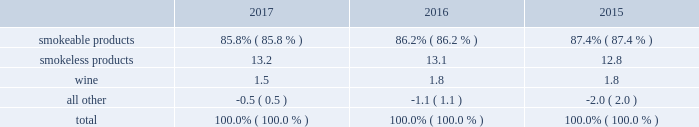10-k altria ar release tuesday , february 27 , 2018 10:00pm andra design llc the relative percentages of operating companies income ( loss ) attributable to each reportable segment and the all other category were as follows: .
For items affecting the comparability of the relative percentages of operating companies income ( loss ) attributable to each reportable segment , see note 15 .
Narrative description of business portions of the information called for by this item are included in operating results by business segment in item 7 .
Management 2019s discussion and analysis of financial condition and results of operations of this annual report on form 10-k ( 201citem 7 201d ) .
Tobacco space altria group , inc . 2019s tobacco operating companies include pm usa , usstc and other subsidiaries of ust , middleton , nu mark and nat sherman .
Altria group distribution company provides sales and distribution services to altria group , inc . 2019s tobacco operating companies .
The products of altria group , inc . 2019s tobacco subsidiaries include smokeable tobacco products , consisting of cigarettes manufactured and sold by pm usa and nat sherman , machine- made large cigars and pipe tobacco manufactured and sold by middleton and premium cigars sold by nat sherman ; smokeless tobacco products manufactured and sold by usstc ; and innovative tobacco products , including e-vapor products manufactured and sold by nu mark .
Cigarettes : pm usa is the largest cigarette company in the united states .
Marlboro , the principal cigarette brand of pm usa , has been the largest-selling cigarette brand in the united states for over 40 years .
Nat sherman sells substantially all of its super premium cigarettes in the united states .
Total smokeable products segment 2019s cigarettes shipment volume in the united states was 116.6 billion units in 2017 , a decrease of 5.1% ( 5.1 % ) from cigars : middleton is engaged in the manufacture and sale of machine-made large cigars and pipe tobacco .
Middleton contracts with a third-party importer to supply a majority of its cigars and sells substantially all of its cigars to customers in the united states .
Black & mild is the principal cigar brand of middleton .
Nat sherman sources all of its cigars from third-party suppliers and sells substantially all of its cigars to customers in the united states .
Total smokeable products segment 2019s cigars shipment volume was approximately 1.5 billion units in 2017 , an increase of 9.9% ( 9.9 % ) from 2016 .
Smokeless tobacco products : usstc is the leading producer and marketer of moist smokeless tobacco ( 201cmst 201d ) products .
The smokeless products segment includes the premium brands , copenhagen and skoal , and value brands , red seal and husky .
Substantially all of the smokeless tobacco products are manufactured and sold to customers in the united states .
Total smokeless products segment 2019s shipment volume was 841.3 million units in 2017 , a decrease of 1.4% ( 1.4 % ) from 2016 .
Innovative tobacco products : nu mark participates in the e-vapor category and has developed and commercialized other innovative tobacco products .
In addition , nu mark sources the production of its e-vapor products through overseas contract manufacturing arrangements .
In 2013 , nu mark introduced markten e-vapor products .
In april 2014 , nu mark acquired the e-vapor business of green smoke , inc .
And its affiliates ( 201cgreen smoke 201d ) , which began selling e-vapor products in 2009 .
In 2017 , altria group , inc . 2019s subsidiaries purchased certain intellectual property related to innovative tobacco products .
In december 2013 , altria group , inc . 2019s subsidiaries entered into a series of agreements with philip morris international inc .
( 201cpmi 201d ) pursuant to which altria group , inc . 2019s subsidiaries provide an exclusive license to pmi to sell nu mark 2019s e-vapor products outside the united states , and pmi 2019s subsidiaries provide an exclusive license to altria group , inc . 2019s subsidiaries to sell two of pmi 2019s heated tobacco product platforms in the united states .
Further , in july 2015 , altria group , inc .
Announced the expansion of its strategic framework with pmi to include a joint research , development and technology-sharing agreement .
Under this agreement , altria group , inc . 2019s subsidiaries and pmi will collaborate to develop e-vapor products for commercialization in the united states by altria group , inc . 2019s subsidiaries and in markets outside the united states by pmi .
This agreement also provides for exclusive technology cross licenses , technical information sharing and cooperation on scientific assessment , regulatory engagement and approval related to e-vapor products .
In the fourth quarter of 2016 , pmi submitted a modified risk tobacco product ( 201cmrtp 201d ) application for an electronically heated tobacco product with the united states food and drug administration 2019s ( 201cfda 201d ) center for tobacco products and filed its corresponding pre-market tobacco product application in the first quarter of 2017 .
Upon regulatory authorization by the fda , altria group , inc . 2019s subsidiaries will have an exclusive license to sell this heated tobacco product in the united states .
Distribution , competition and raw materials : altria group , inc . 2019s tobacco subsidiaries sell their tobacco products principally to wholesalers ( including distributors ) , large retail organizations , including chain stores , and the armed services .
The market for tobacco products is highly competitive , characterized by brand recognition and loyalty , with product quality , taste , price , product innovation , marketing , packaging and distribution constituting the significant methods of competition .
Promotional activities include , in certain instances and where permitted by law , allowances , the distribution of incentive items , price promotions , product promotions , coupons and other discounts. .
What is the percent change in relative percentages of operating companies income ( loss ) attributable to smokeless products from 2015 to 2016? 
Computations: (13.1 - 12.8)
Answer: 0.3. 10-k altria ar release tuesday , february 27 , 2018 10:00pm andra design llc the relative percentages of operating companies income ( loss ) attributable to each reportable segment and the all other category were as follows: .
For items affecting the comparability of the relative percentages of operating companies income ( loss ) attributable to each reportable segment , see note 15 .
Narrative description of business portions of the information called for by this item are included in operating results by business segment in item 7 .
Management 2019s discussion and analysis of financial condition and results of operations of this annual report on form 10-k ( 201citem 7 201d ) .
Tobacco space altria group , inc . 2019s tobacco operating companies include pm usa , usstc and other subsidiaries of ust , middleton , nu mark and nat sherman .
Altria group distribution company provides sales and distribution services to altria group , inc . 2019s tobacco operating companies .
The products of altria group , inc . 2019s tobacco subsidiaries include smokeable tobacco products , consisting of cigarettes manufactured and sold by pm usa and nat sherman , machine- made large cigars and pipe tobacco manufactured and sold by middleton and premium cigars sold by nat sherman ; smokeless tobacco products manufactured and sold by usstc ; and innovative tobacco products , including e-vapor products manufactured and sold by nu mark .
Cigarettes : pm usa is the largest cigarette company in the united states .
Marlboro , the principal cigarette brand of pm usa , has been the largest-selling cigarette brand in the united states for over 40 years .
Nat sherman sells substantially all of its super premium cigarettes in the united states .
Total smokeable products segment 2019s cigarettes shipment volume in the united states was 116.6 billion units in 2017 , a decrease of 5.1% ( 5.1 % ) from cigars : middleton is engaged in the manufacture and sale of machine-made large cigars and pipe tobacco .
Middleton contracts with a third-party importer to supply a majority of its cigars and sells substantially all of its cigars to customers in the united states .
Black & mild is the principal cigar brand of middleton .
Nat sherman sources all of its cigars from third-party suppliers and sells substantially all of its cigars to customers in the united states .
Total smokeable products segment 2019s cigars shipment volume was approximately 1.5 billion units in 2017 , an increase of 9.9% ( 9.9 % ) from 2016 .
Smokeless tobacco products : usstc is the leading producer and marketer of moist smokeless tobacco ( 201cmst 201d ) products .
The smokeless products segment includes the premium brands , copenhagen and skoal , and value brands , red seal and husky .
Substantially all of the smokeless tobacco products are manufactured and sold to customers in the united states .
Total smokeless products segment 2019s shipment volume was 841.3 million units in 2017 , a decrease of 1.4% ( 1.4 % ) from 2016 .
Innovative tobacco products : nu mark participates in the e-vapor category and has developed and commercialized other innovative tobacco products .
In addition , nu mark sources the production of its e-vapor products through overseas contract manufacturing arrangements .
In 2013 , nu mark introduced markten e-vapor products .
In april 2014 , nu mark acquired the e-vapor business of green smoke , inc .
And its affiliates ( 201cgreen smoke 201d ) , which began selling e-vapor products in 2009 .
In 2017 , altria group , inc . 2019s subsidiaries purchased certain intellectual property related to innovative tobacco products .
In december 2013 , altria group , inc . 2019s subsidiaries entered into a series of agreements with philip morris international inc .
( 201cpmi 201d ) pursuant to which altria group , inc . 2019s subsidiaries provide an exclusive license to pmi to sell nu mark 2019s e-vapor products outside the united states , and pmi 2019s subsidiaries provide an exclusive license to altria group , inc . 2019s subsidiaries to sell two of pmi 2019s heated tobacco product platforms in the united states .
Further , in july 2015 , altria group , inc .
Announced the expansion of its strategic framework with pmi to include a joint research , development and technology-sharing agreement .
Under this agreement , altria group , inc . 2019s subsidiaries and pmi will collaborate to develop e-vapor products for commercialization in the united states by altria group , inc . 2019s subsidiaries and in markets outside the united states by pmi .
This agreement also provides for exclusive technology cross licenses , technical information sharing and cooperation on scientific assessment , regulatory engagement and approval related to e-vapor products .
In the fourth quarter of 2016 , pmi submitted a modified risk tobacco product ( 201cmrtp 201d ) application for an electronically heated tobacco product with the united states food and drug administration 2019s ( 201cfda 201d ) center for tobacco products and filed its corresponding pre-market tobacco product application in the first quarter of 2017 .
Upon regulatory authorization by the fda , altria group , inc . 2019s subsidiaries will have an exclusive license to sell this heated tobacco product in the united states .
Distribution , competition and raw materials : altria group , inc . 2019s tobacco subsidiaries sell their tobacco products principally to wholesalers ( including distributors ) , large retail organizations , including chain stores , and the armed services .
The market for tobacco products is highly competitive , characterized by brand recognition and loyalty , with product quality , taste , price , product innovation , marketing , packaging and distribution constituting the significant methods of competition .
Promotional activities include , in certain instances and where permitted by law , allowances , the distribution of incentive items , price promotions , product promotions , coupons and other discounts. .
What is the percentage change in the weight of smokeless products in operating income from 2016 to 2017? 
Computations: ((13.2 - 13.1) / 13.1)
Answer: 0.00763. 10-k altria ar release tuesday , february 27 , 2018 10:00pm andra design llc the relative percentages of operating companies income ( loss ) attributable to each reportable segment and the all other category were as follows: .
For items affecting the comparability of the relative percentages of operating companies income ( loss ) attributable to each reportable segment , see note 15 .
Narrative description of business portions of the information called for by this item are included in operating results by business segment in item 7 .
Management 2019s discussion and analysis of financial condition and results of operations of this annual report on form 10-k ( 201citem 7 201d ) .
Tobacco space altria group , inc . 2019s tobacco operating companies include pm usa , usstc and other subsidiaries of ust , middleton , nu mark and nat sherman .
Altria group distribution company provides sales and distribution services to altria group , inc . 2019s tobacco operating companies .
The products of altria group , inc . 2019s tobacco subsidiaries include smokeable tobacco products , consisting of cigarettes manufactured and sold by pm usa and nat sherman , machine- made large cigars and pipe tobacco manufactured and sold by middleton and premium cigars sold by nat sherman ; smokeless tobacco products manufactured and sold by usstc ; and innovative tobacco products , including e-vapor products manufactured and sold by nu mark .
Cigarettes : pm usa is the largest cigarette company in the united states .
Marlboro , the principal cigarette brand of pm usa , has been the largest-selling cigarette brand in the united states for over 40 years .
Nat sherman sells substantially all of its super premium cigarettes in the united states .
Total smokeable products segment 2019s cigarettes shipment volume in the united states was 116.6 billion units in 2017 , a decrease of 5.1% ( 5.1 % ) from cigars : middleton is engaged in the manufacture and sale of machine-made large cigars and pipe tobacco .
Middleton contracts with a third-party importer to supply a majority of its cigars and sells substantially all of its cigars to customers in the united states .
Black & mild is the principal cigar brand of middleton .
Nat sherman sources all of its cigars from third-party suppliers and sells substantially all of its cigars to customers in the united states .
Total smokeable products segment 2019s cigars shipment volume was approximately 1.5 billion units in 2017 , an increase of 9.9% ( 9.9 % ) from 2016 .
Smokeless tobacco products : usstc is the leading producer and marketer of moist smokeless tobacco ( 201cmst 201d ) products .
The smokeless products segment includes the premium brands , copenhagen and skoal , and value brands , red seal and husky .
Substantially all of the smokeless tobacco products are manufactured and sold to customers in the united states .
Total smokeless products segment 2019s shipment volume was 841.3 million units in 2017 , a decrease of 1.4% ( 1.4 % ) from 2016 .
Innovative tobacco products : nu mark participates in the e-vapor category and has developed and commercialized other innovative tobacco products .
In addition , nu mark sources the production of its e-vapor products through overseas contract manufacturing arrangements .
In 2013 , nu mark introduced markten e-vapor products .
In april 2014 , nu mark acquired the e-vapor business of green smoke , inc .
And its affiliates ( 201cgreen smoke 201d ) , which began selling e-vapor products in 2009 .
In 2017 , altria group , inc . 2019s subsidiaries purchased certain intellectual property related to innovative tobacco products .
In december 2013 , altria group , inc . 2019s subsidiaries entered into a series of agreements with philip morris international inc .
( 201cpmi 201d ) pursuant to which altria group , inc . 2019s subsidiaries provide an exclusive license to pmi to sell nu mark 2019s e-vapor products outside the united states , and pmi 2019s subsidiaries provide an exclusive license to altria group , inc . 2019s subsidiaries to sell two of pmi 2019s heated tobacco product platforms in the united states .
Further , in july 2015 , altria group , inc .
Announced the expansion of its strategic framework with pmi to include a joint research , development and technology-sharing agreement .
Under this agreement , altria group , inc . 2019s subsidiaries and pmi will collaborate to develop e-vapor products for commercialization in the united states by altria group , inc . 2019s subsidiaries and in markets outside the united states by pmi .
This agreement also provides for exclusive technology cross licenses , technical information sharing and cooperation on scientific assessment , regulatory engagement and approval related to e-vapor products .
In the fourth quarter of 2016 , pmi submitted a modified risk tobacco product ( 201cmrtp 201d ) application for an electronically heated tobacco product with the united states food and drug administration 2019s ( 201cfda 201d ) center for tobacco products and filed its corresponding pre-market tobacco product application in the first quarter of 2017 .
Upon regulatory authorization by the fda , altria group , inc . 2019s subsidiaries will have an exclusive license to sell this heated tobacco product in the united states .
Distribution , competition and raw materials : altria group , inc . 2019s tobacco subsidiaries sell their tobacco products principally to wholesalers ( including distributors ) , large retail organizations , including chain stores , and the armed services .
The market for tobacco products is highly competitive , characterized by brand recognition and loyalty , with product quality , taste , price , product innovation , marketing , packaging and distribution constituting the significant methods of competition .
Promotional activities include , in certain instances and where permitted by law , allowances , the distribution of incentive items , price promotions , product promotions , coupons and other discounts. .
What is the percentage change in the weight of smokeless products in operating income from 2015 to 2016? 
Computations: ((13.1 - 12.8) / 12.8)
Answer: 0.02344. 